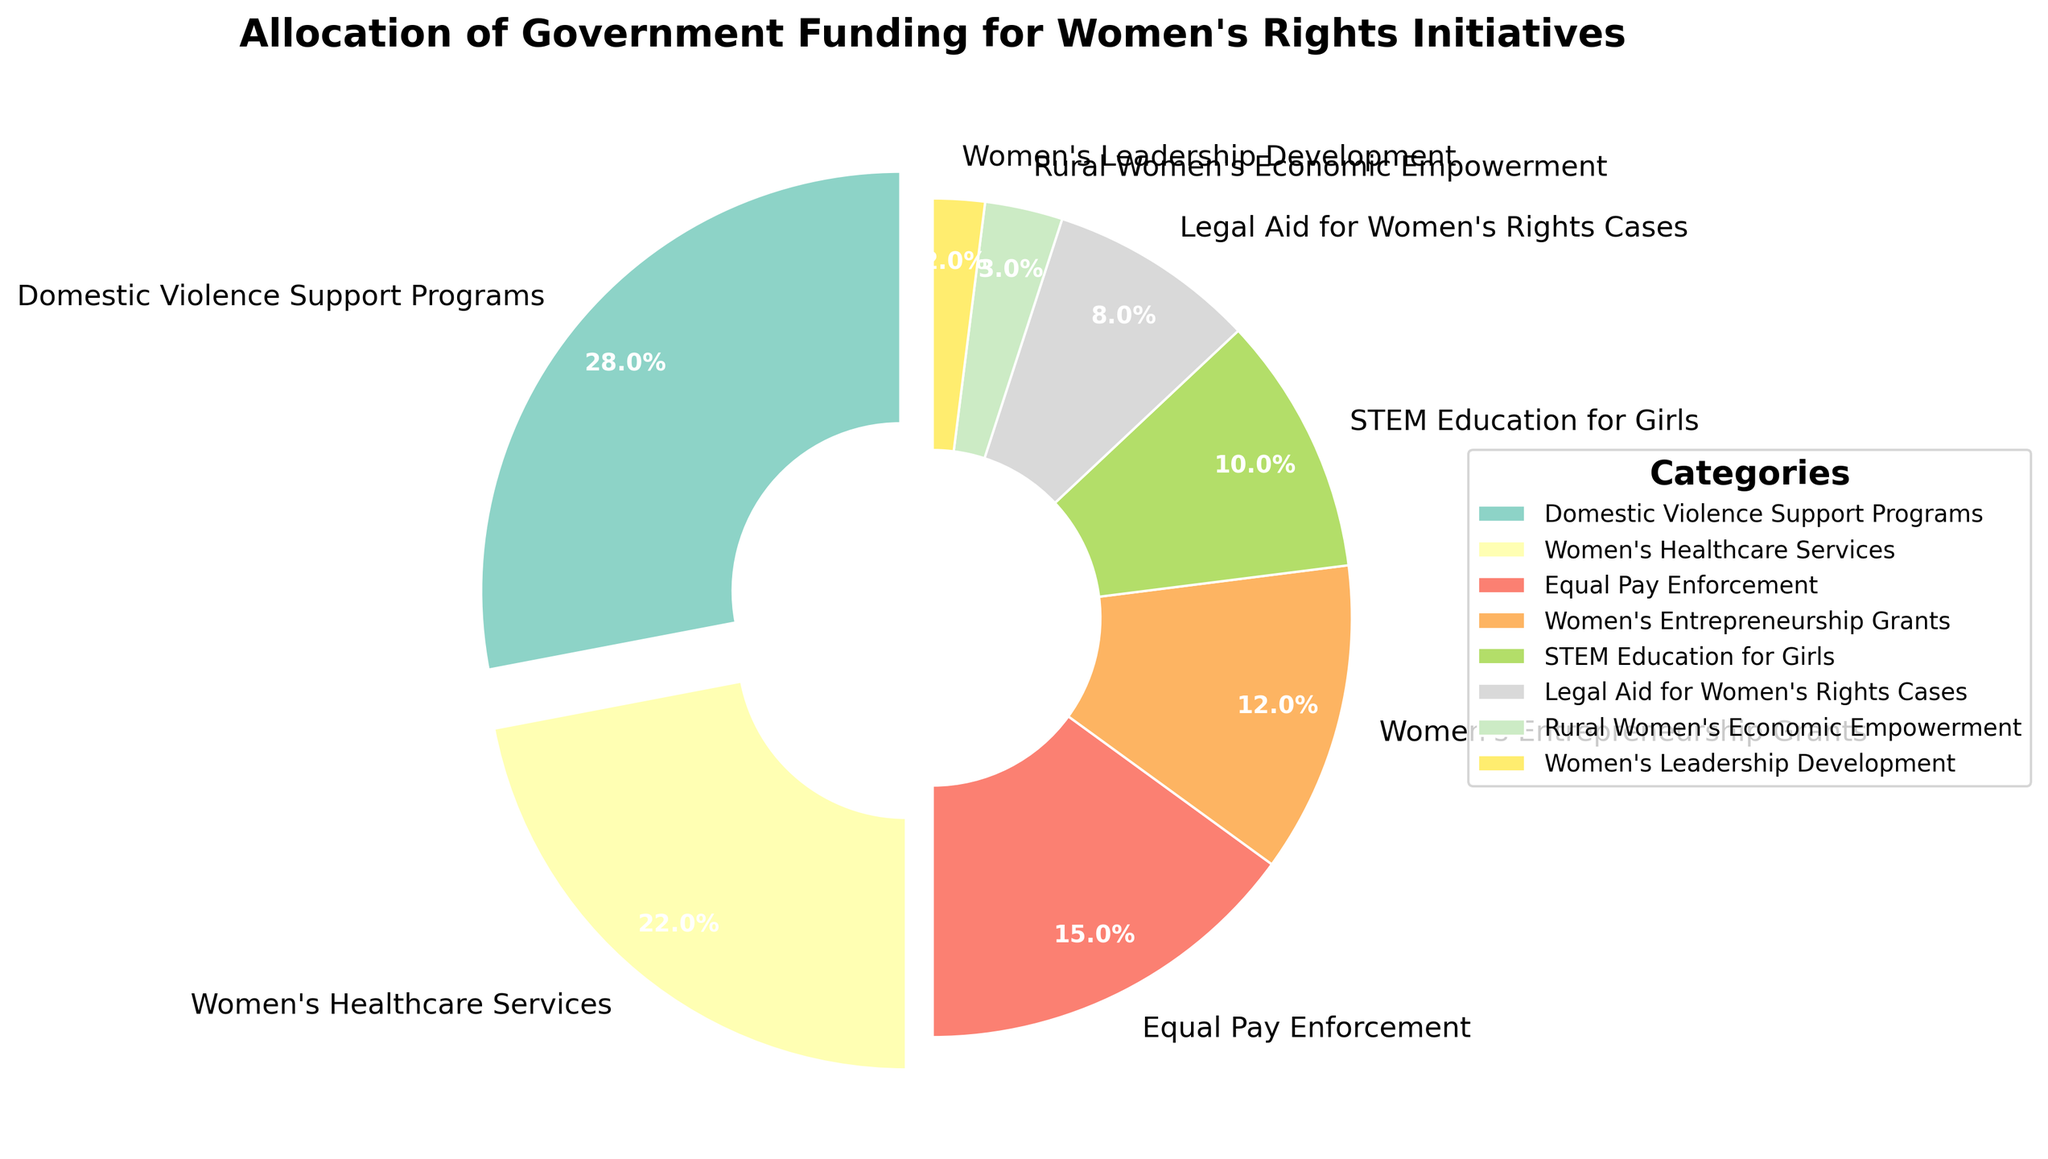Which category receives the highest allocation of government funding? The pie chart shows different categories with their corresponding percentage allocations. The largest segment is clearly labeled as "Domestic Violence Support Programs" which has the largest percentage.
Answer: Domestic Violence Support Programs Which two categories together receive the same amount of funding as Women's Healthcare Services? From the chart, Women's Healthcare Services has a 22% allocation. Looking at the other categories, adding Equal Pay Enforcement (15%) and Women's Entrepreneurship Grants (12%) exceeds this amount, but adding Equal Pay Enforcement (15%) and STEM Education for Girls (10%) is closest, given their combined total is 25%, which is the closest sum to 22%.
Answer: Equal Pay Enforcement and STEM Education for Girls How does the funding for Women's Leadership Development compare to that for Legal Aid for Women's Rights Cases? The chart's segments for Women's Leadership Development and Legal Aid for Women's Rights Cases show 2% and 8% respectively. By comparison, funding for Women's Leadership Development is less than that for Legal Aid for Women's Rights Cases.
Answer: Less What's the combined funding percentage for categories specifically aimed at economic empowerment (Women's Entrepreneurship Grants and Rural Women's Economic Empowerment)? The chart lists Women's Entrepreneurship Grants at 12% and Rural Women's Economic Empowerment at 3%. Adding these percentages together gives a total of 15%.
Answer: 15% Which category appears in lightest color, and what is its allocated funding percentage? The chart uses different colors, and the lightest color is associated with the smallest segment, Women's Leadership Development, which has a 2% allocation.
Answer: Women's Leadership Development, 2% What is the difference between the funding percentage for Equal Pay Enforcement and STEM Education for Girls? The chart shows Equal Pay Enforcement at 15% and STEM Education for Girls at 10%. The difference between these percentages can be calculated as 15% - 10% = 5%.
Answer: 5% Which category has a funding percentage closest to the average funding percentage across all categories? To find this, first calculate the average percentage. The total percentage allocation is 100%. There are 8 categories, so the average is 100% / 8 = 12.5%. The closest category to this average is Women's Entrepreneurship Grants at 12%.
Answer: Women's Entrepreneurship Grants If the categories receiving more than 10% each combine, what percentage of the total funding would they represent? Categories with more than 10% are Domestic Violence Support Programs (28%), Women's Healthcare Services (22%), Equal Pay Enforcement (15%), and Women's Entrepreneurship Grants (12%). Summing these percentages: 28% + 22% + 15% + 12% = 77%.
Answer: 77% What percentage of the total funding is allocated to services directly supporting women's legal rights (Legal Aid for Women's Rights Cases and Equal Pay Enforcement)? Legal Aid for Women's Rights Cases has 8% and Equal Pay Enforcement has 15%. Adding these together gives 8% + 15% = 23%.
Answer: 23% 